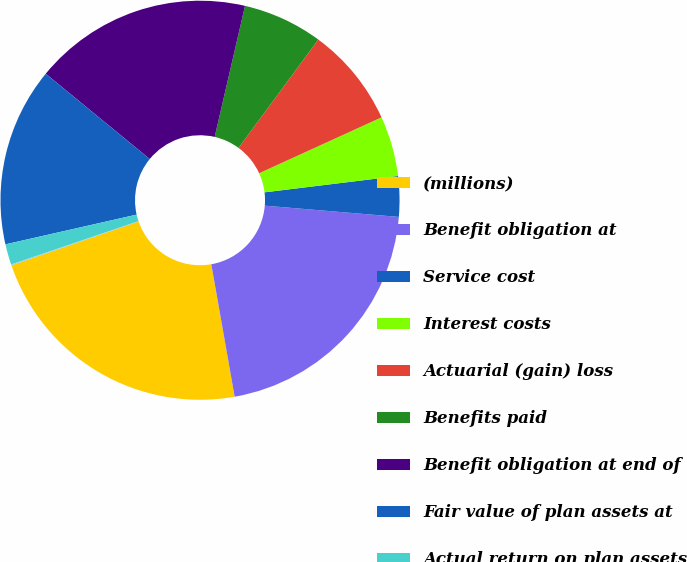<chart> <loc_0><loc_0><loc_500><loc_500><pie_chart><fcel>(millions)<fcel>Benefit obligation at<fcel>Service cost<fcel>Interest costs<fcel>Actuarial (gain) loss<fcel>Benefits paid<fcel>Benefit obligation at end of<fcel>Fair value of plan assets at<fcel>Actual return on plan assets<fcel>Employer contributions<nl><fcel>22.49%<fcel>20.89%<fcel>3.27%<fcel>4.88%<fcel>8.08%<fcel>6.48%<fcel>17.69%<fcel>14.48%<fcel>1.67%<fcel>0.07%<nl></chart> 